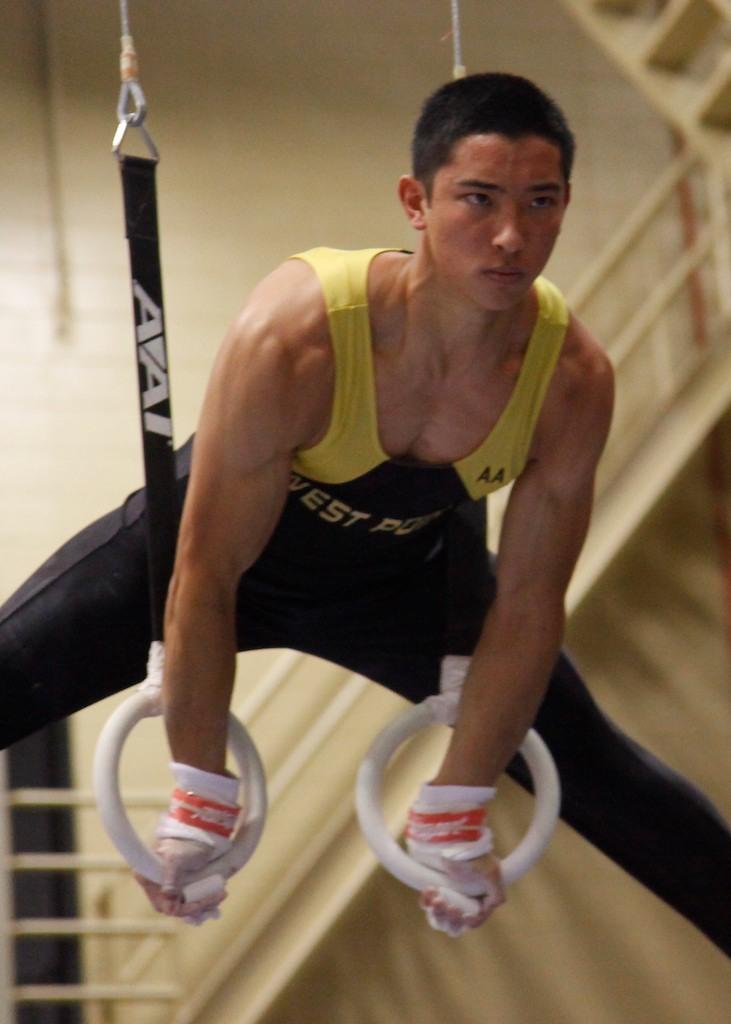What is the brand of equipment or clothing the person is using?
Your response must be concise. Avai. What is the brand of rings?
Provide a succinct answer. Avai. 